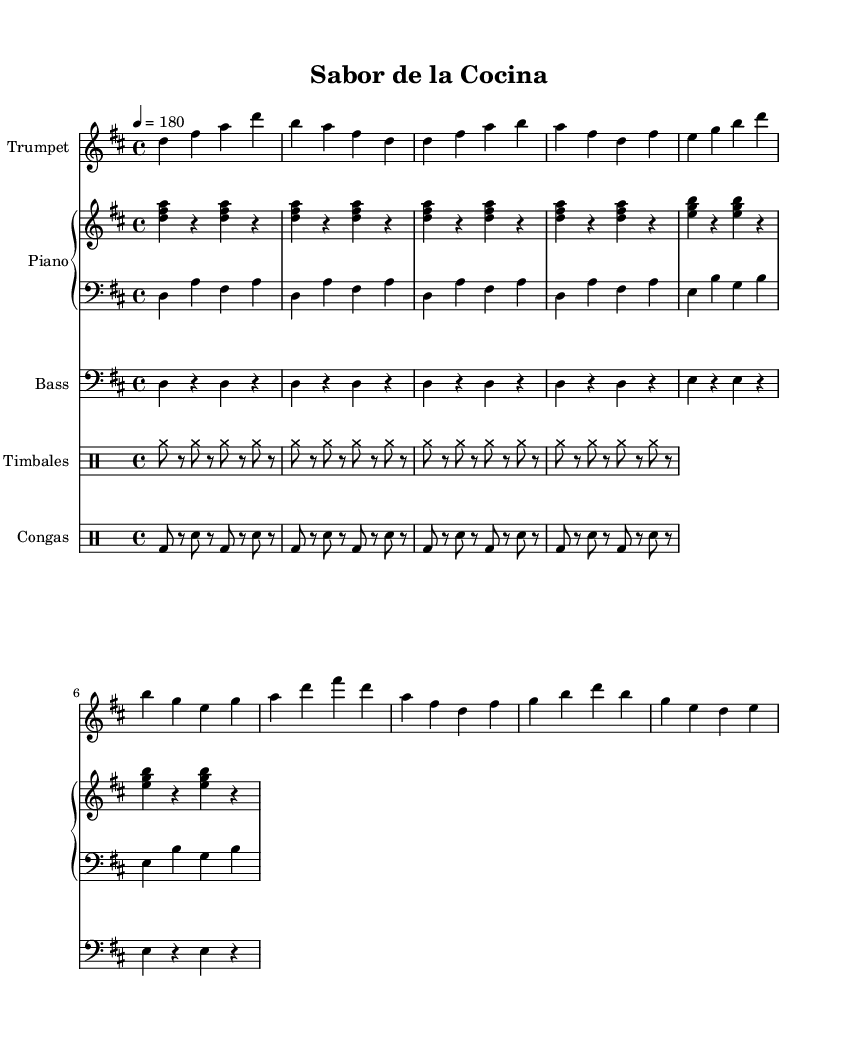What is the key signature of this music? The key signature is D major, which has two sharps (F# and C#). This is determined by looking at the key signature symbol at the beginning of the score.
Answer: D major What is the time signature of this music? The time signature is 4/4, which indicates there are four beats in each measure and the quarter note gets one beat. This information can be found at the beginning of the score where the time signature is indicated.
Answer: 4/4 What is the tempo marking for this piece? The tempo marking indicates a speed of 180 BPM (beats per minute). This is found in the score, where the tempo is typically noted at the beginning.
Answer: 180 How many beats are there in a measure? In a measure, there are four beats, according to the time signature of 4/4. This implies that each measure will contain four quarter note beats, which is consistent throughout the score.
Answer: 4 What instruments are used in this piece? The instruments used are Trumpet, Piano, Bass, Timbales, and Congas. This information is found at the beginning of each respective staff notation in the score, denoting the instrument names.
Answer: Trumpet, Piano, Bass, Timbales, Congas What rhythm pattern does the congas play during the intro? The congas play a rhythm pattern of bass drum and snare, alternating every eighth note. This pattern is notated in the drum staff section specifically for congas, indicating the sequence of sounds.
Answer: Bass-Snare What type of music is this? This music is Salsa, as indicated by the dance style characteristic of the upbeat tempo, rhythmic complexity, and instrumentation typical of Latin music. This can be inferred from the title "Sabor de la Cocina" and the style portrayed in the score.
Answer: Salsa 